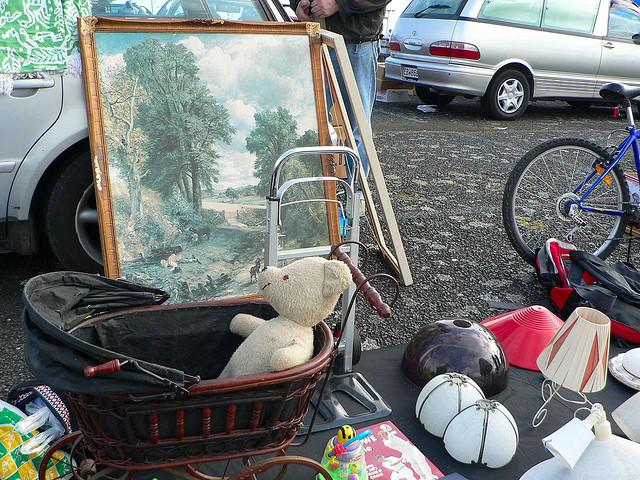What is the teddy bear in?
Answer briefly. Stroller. Is this a flea market?
Answer briefly. Yes. What color is the bike?
Be succinct. Blue. 